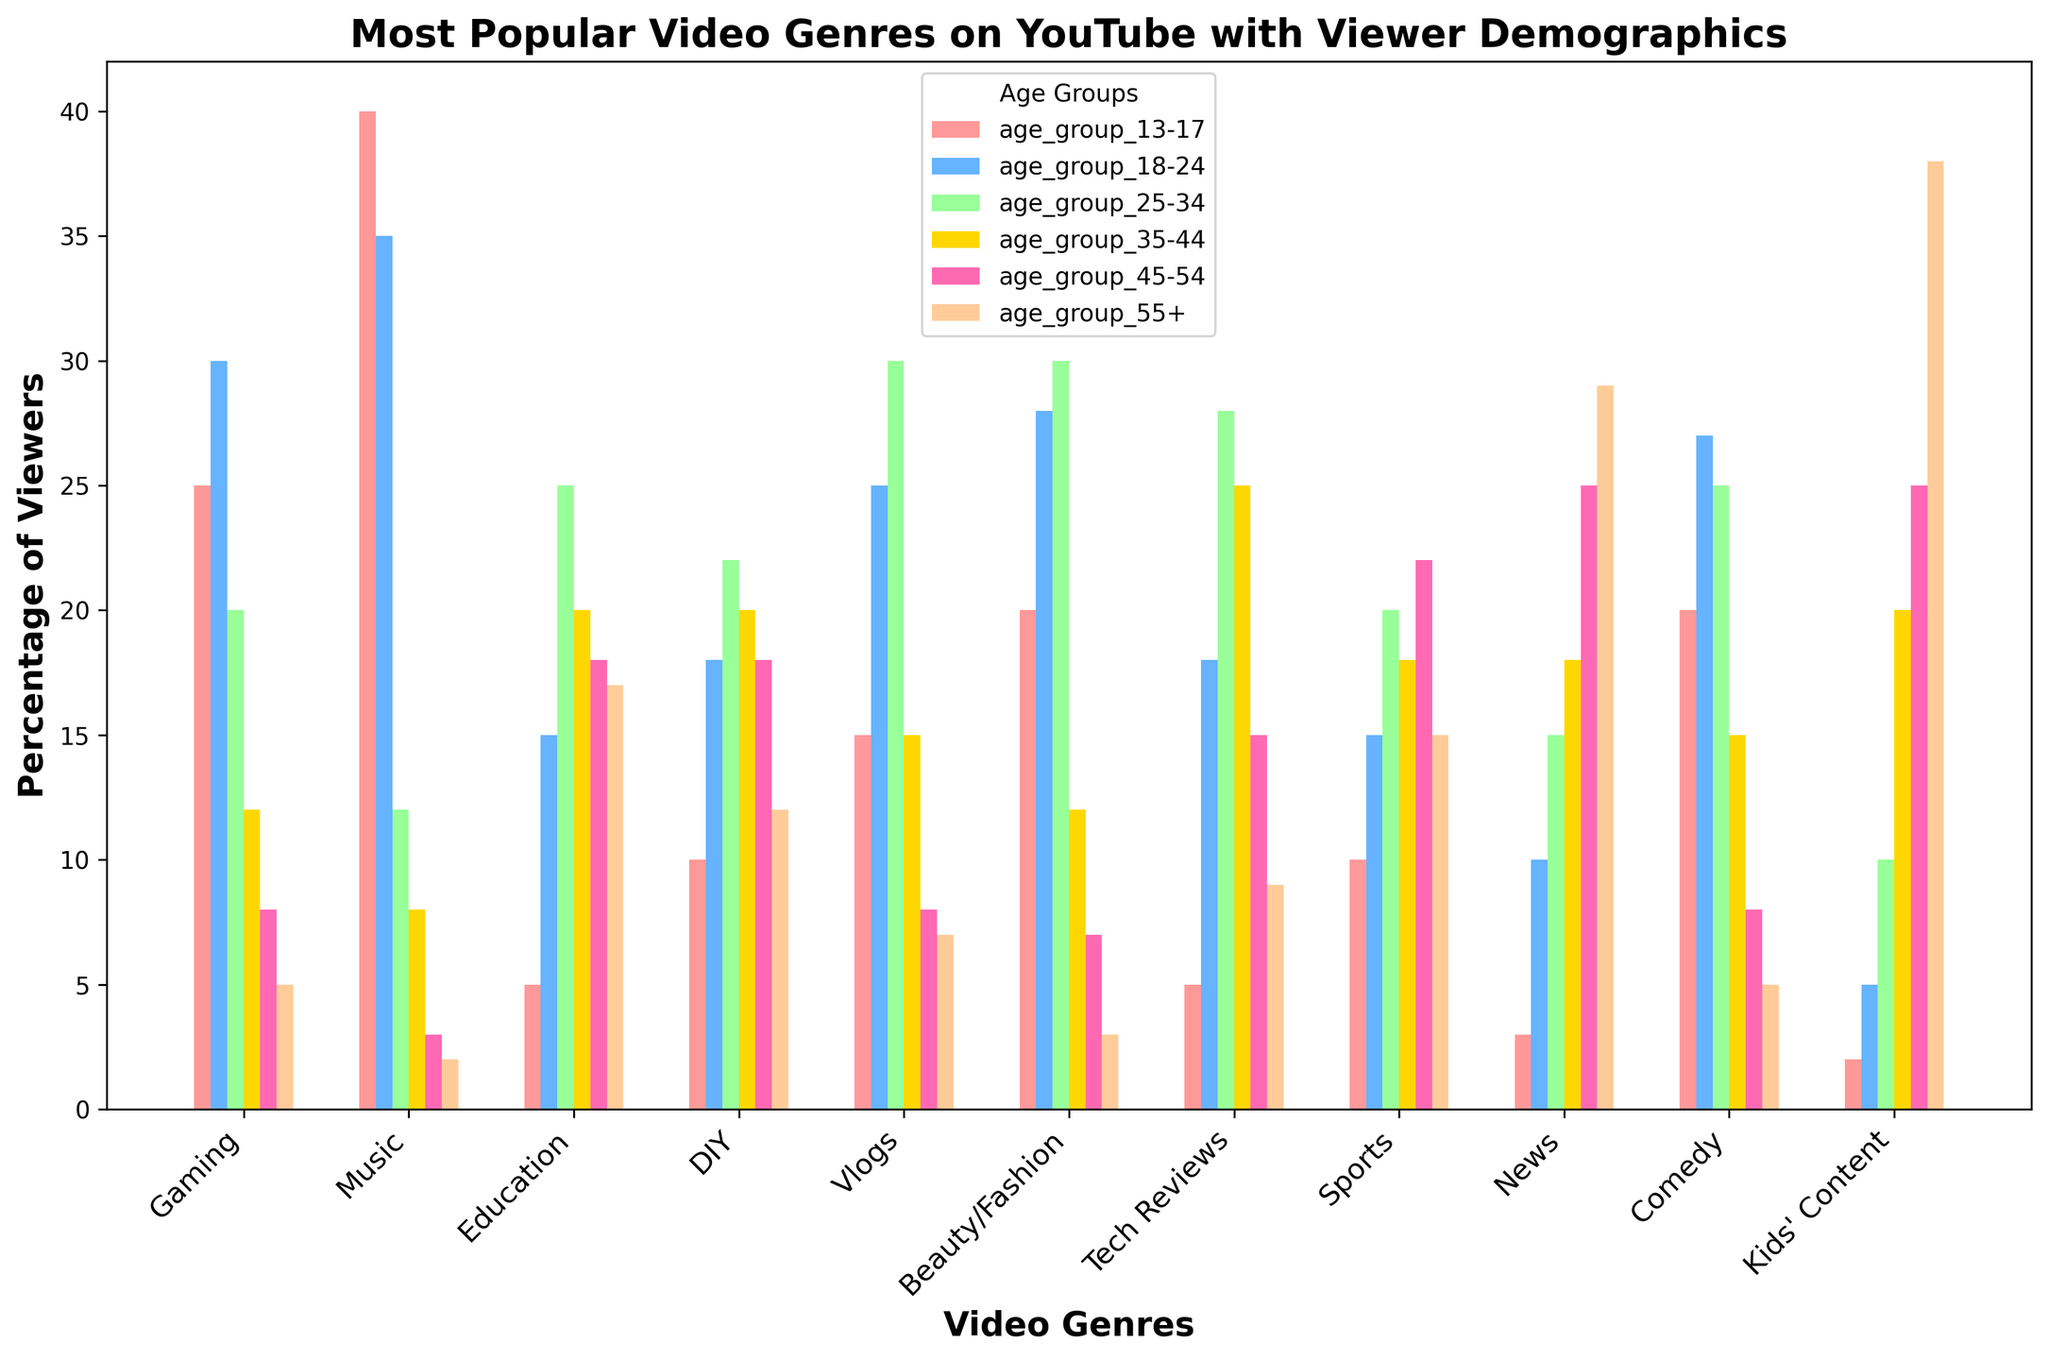What is the most popular genre among viewers aged 13-17? Look for the highest bar for the age group "13-17". The "Music" genre has the tallest bar in that section.
Answer: Music Which genre is least popular among viewers aged 55+? Look for the smallest bar for the age group "55+". The "Music" genre has the shortest bar with 2%.
Answer: Music How do the percentages of viewers aged 35-44 compare between the genres DIY and Tech Reviews? Find the heights of the bars for the "35-44" age group for both genres. DIY has 20%, and Tech Reviews has 25%. 20% is less than 25%.
Answer: Tech Reviews has a higher percentage Which genre has the largest demographic spread (difference between the highest and lowest percentage across age groups)? Calculate the spreads: 
- Gaming: 30 - 5 = 25
- Music: 40 - 2 = 38
- Education: 25 - 5 = 20
- DIY: 22 - 10 = 12
- Vlogs: 30 - 7 = 23
- Beauty/Fashion: 30 - 3 = 27
- Tech Reviews: 28 - 5 = 23
- Sports: 22 - 10 = 12
- News: 29 - 3 = 26
- Comedy: 27 - 5 = 22
- Kids’ Content: 38 - 2 = 36
Music has the highest spread of 38%.
Answer: Music Which genre has more viewers aged 25-34, Vlogs or Beauty/Fashion? By how much? Find the heights of the bars for the "25-34" age group for both genres. Vlogs: 30%, Beauty/Fashion: 30%. The difference in viewers for both genres is 0.
Answer: Vlogs and Beauty/Fashion are equal In which genre do people aged 45-54 comprise the largest portion of the audience? Look for the highest bar in the "45-54" age group. The "Kids' Content" genre has the tallest bar in that section with 25%.
Answer: Kids’ Content Calculate the average viewer percentage for the Music genre across all age groups. Sum the values and divide by the number of age groups:
(40 + 35 + 12 + 8 + 3 + 2) / 6 = 100 / 6 ≈ 16.67
Answer: 16.67 Which genre has the highest combined viewer percentage for age groups 18-24 and 25-34? Sum the viewer percentages for each genre across the two age groups:
- Gaming: 30 + 20 = 50
- Music: 35 + 12 = 47
- Education: 15 + 25 = 40
- DIY: 18 + 22 = 40
- Vlogs: 25 + 30 = 55
- Beauty/Fashion: 28 + 30 = 58
- Tech Reviews: 18 + 28 = 46
- Sports: 15 + 20 = 35
- News: 10 + 15 = 25
- Comedy: 27 + 25 = 52
- Kids’ Content: 5 + 10 = 15
The genre Beauty/Fashion has the highest combined viewer percentage of 58%.
Answer: Beauty/Fashion If you sum the percentages for the Vlogs genre across all age groups, what is the total? Add all values for the Vlogs genre across all age groups:
15 + 25 + 30 + 15 + 8 + 7 = 100
Answer: 100 